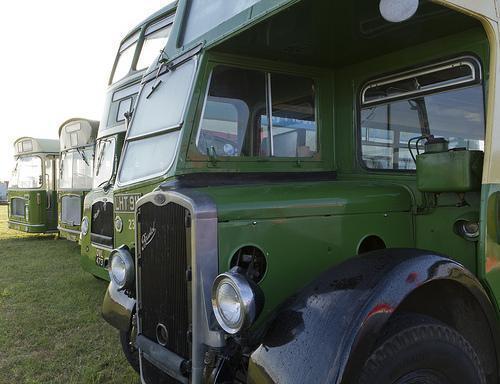How many trucks are are in the picture?
Give a very brief answer. 1. 